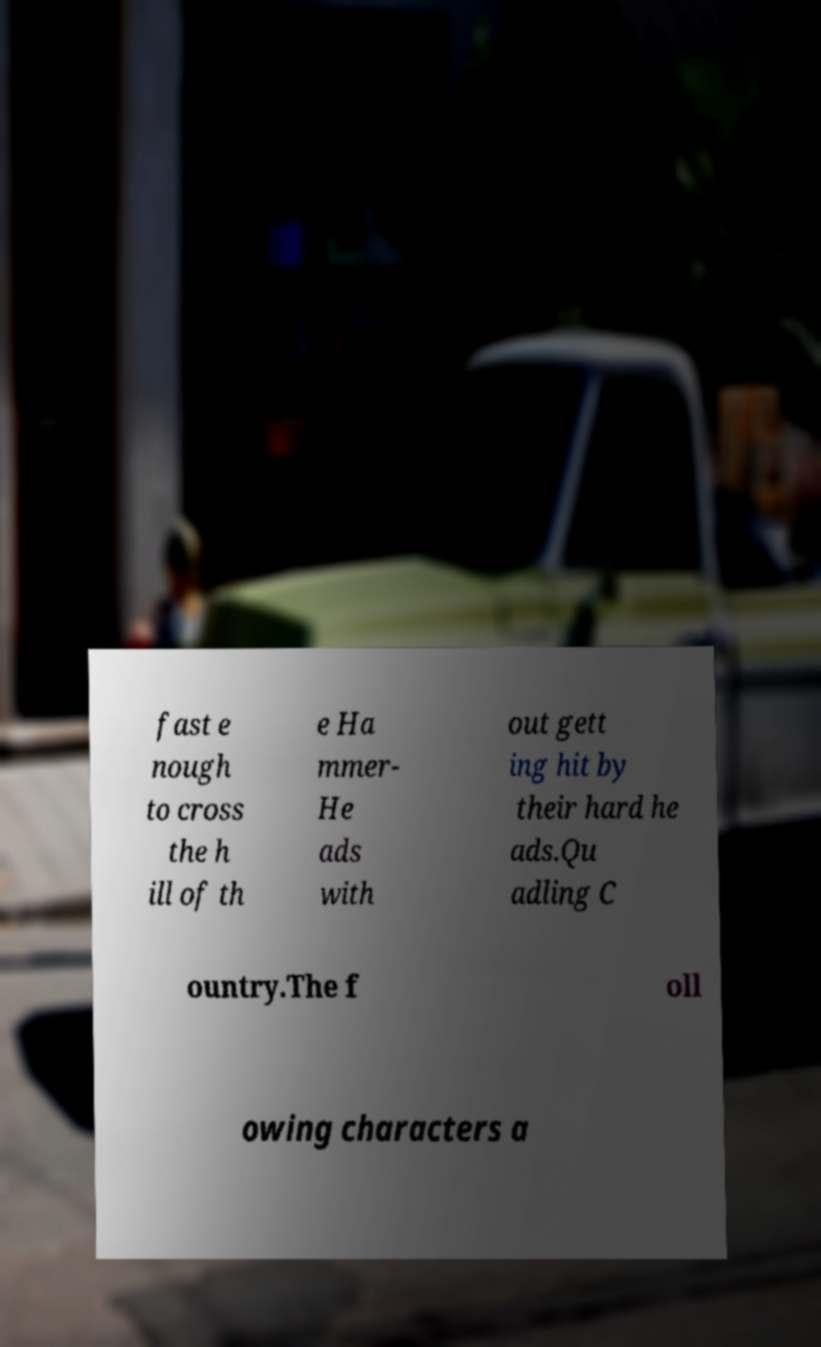Can you read and provide the text displayed in the image?This photo seems to have some interesting text. Can you extract and type it out for me? fast e nough to cross the h ill of th e Ha mmer- He ads with out gett ing hit by their hard he ads.Qu adling C ountry.The f oll owing characters a 